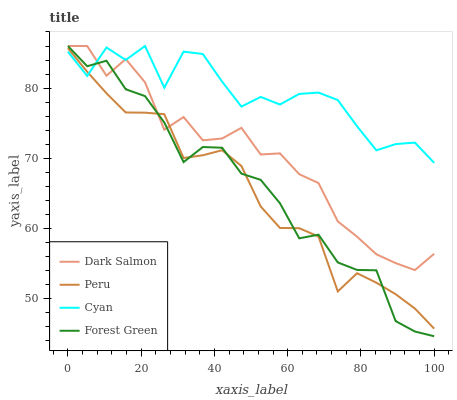Does Forest Green have the minimum area under the curve?
Answer yes or no. No. Does Forest Green have the maximum area under the curve?
Answer yes or no. No. Is Forest Green the smoothest?
Answer yes or no. No. Is Forest Green the roughest?
Answer yes or no. No. Does Dark Salmon have the lowest value?
Answer yes or no. No. Does Peru have the highest value?
Answer yes or no. No. 